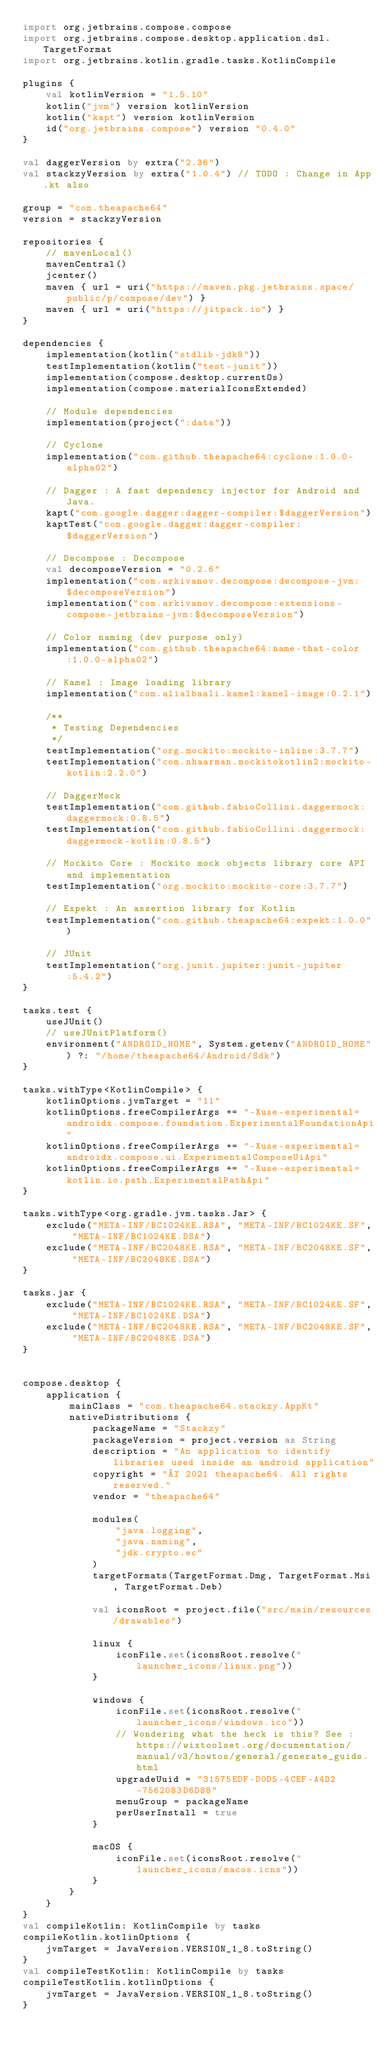Convert code to text. <code><loc_0><loc_0><loc_500><loc_500><_Kotlin_>import org.jetbrains.compose.compose
import org.jetbrains.compose.desktop.application.dsl.TargetFormat
import org.jetbrains.kotlin.gradle.tasks.KotlinCompile

plugins {
    val kotlinVersion = "1.5.10"
    kotlin("jvm") version kotlinVersion
    kotlin("kapt") version kotlinVersion
    id("org.jetbrains.compose") version "0.4.0"
}

val daggerVersion by extra("2.36")
val stackzyVersion by extra("1.0.4") // TODO : Change in App.kt also

group = "com.theapache64"
version = stackzyVersion

repositories {
    // mavenLocal()
    mavenCentral()
    jcenter()
    maven { url = uri("https://maven.pkg.jetbrains.space/public/p/compose/dev") }
    maven { url = uri("https://jitpack.io") }
}

dependencies {
    implementation(kotlin("stdlib-jdk8"))
    testImplementation(kotlin("test-junit"))
    implementation(compose.desktop.currentOs)
    implementation(compose.materialIconsExtended)

    // Module dependencies
    implementation(project(":data"))

    // Cyclone
    implementation("com.github.theapache64:cyclone:1.0.0-alpha02")

    // Dagger : A fast dependency injector for Android and Java.
    kapt("com.google.dagger:dagger-compiler:$daggerVersion")
    kaptTest("com.google.dagger:dagger-compiler:$daggerVersion")

    // Decompose : Decompose
    val decomposeVersion = "0.2.6"
    implementation("com.arkivanov.decompose:decompose-jvm:$decomposeVersion")
    implementation("com.arkivanov.decompose:extensions-compose-jetbrains-jvm:$decomposeVersion")

    // Color naming (dev purpose only)
    implementation("com.github.theapache64:name-that-color:1.0.0-alpha02")

    // Kamel : Image loading library
    implementation("com.alialbaali.kamel:kamel-image:0.2.1")

    /**
     * Testing Dependencies
     */
    testImplementation("org.mockito:mockito-inline:3.7.7")
    testImplementation("com.nhaarman.mockitokotlin2:mockito-kotlin:2.2.0")

    // DaggerMock
    testImplementation("com.github.fabioCollini.daggermock:daggermock:0.8.5")
    testImplementation("com.github.fabioCollini.daggermock:daggermock-kotlin:0.8.5")

    // Mockito Core : Mockito mock objects library core API and implementation
    testImplementation("org.mockito:mockito-core:3.7.7")

    // Expekt : An assertion library for Kotlin
    testImplementation("com.github.theapache64:expekt:1.0.0")

    // JUnit
    testImplementation("org.junit.jupiter:junit-jupiter:5.4.2")
}

tasks.test {
    useJUnit()
    // useJUnitPlatform()
    environment("ANDROID_HOME", System.getenv("ANDROID_HOME") ?: "/home/theapache64/Android/Sdk")
}

tasks.withType<KotlinCompile> {
    kotlinOptions.jvmTarget = "11"
    kotlinOptions.freeCompilerArgs += "-Xuse-experimental=androidx.compose.foundation.ExperimentalFoundationApi"
    kotlinOptions.freeCompilerArgs += "-Xuse-experimental=androidx.compose.ui.ExperimentalComposeUiApi"
    kotlinOptions.freeCompilerArgs += "-Xuse-experimental=kotlin.io.path.ExperimentalPathApi"
}

tasks.withType<org.gradle.jvm.tasks.Jar> {
    exclude("META-INF/BC1024KE.RSA", "META-INF/BC1024KE.SF", "META-INF/BC1024KE.DSA")
    exclude("META-INF/BC2048KE.RSA", "META-INF/BC2048KE.SF", "META-INF/BC2048KE.DSA")
}

tasks.jar {
    exclude("META-INF/BC1024KE.RSA", "META-INF/BC1024KE.SF", "META-INF/BC1024KE.DSA")
    exclude("META-INF/BC2048KE.RSA", "META-INF/BC2048KE.SF", "META-INF/BC2048KE.DSA")
}


compose.desktop {
    application {
        mainClass = "com.theapache64.stackzy.AppKt"
        nativeDistributions {
            packageName = "Stackzy"
            packageVersion = project.version as String
            description = "An application to identify libraries used inside an android application"
            copyright = "© 2021 theapache64. All rights reserved."
            vendor = "theapache64"

            modules(
                "java.logging",
                "java.naming",
                "jdk.crypto.ec"
            )
            targetFormats(TargetFormat.Dmg, TargetFormat.Msi, TargetFormat.Deb)

            val iconsRoot = project.file("src/main/resources/drawables")

            linux {
                iconFile.set(iconsRoot.resolve("launcher_icons/linux.png"))
            }

            windows {
                iconFile.set(iconsRoot.resolve("launcher_icons/windows.ico"))
                // Wondering what the heck is this? See : https://wixtoolset.org/documentation/manual/v3/howtos/general/generate_guids.html
                upgradeUuid = "31575EDF-D0D5-4CEF-A4D2-7562083D6D88"
                menuGroup = packageName
                perUserInstall = true
            }

            macOS {
                iconFile.set(iconsRoot.resolve("launcher_icons/macos.icns"))
            }
        }
    }
}
val compileKotlin: KotlinCompile by tasks
compileKotlin.kotlinOptions {
    jvmTarget = JavaVersion.VERSION_1_8.toString()
}
val compileTestKotlin: KotlinCompile by tasks
compileTestKotlin.kotlinOptions {
    jvmTarget = JavaVersion.VERSION_1_8.toString()
}</code> 